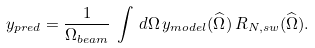<formula> <loc_0><loc_0><loc_500><loc_500>y _ { p r e d } = \frac { 1 } { \Omega _ { b e a m } } \, \int \, d \Omega \, y _ { m o d e l } ( \widehat { \Omega } ) \, R _ { N , s w } ( \widehat { \Omega } ) .</formula> 